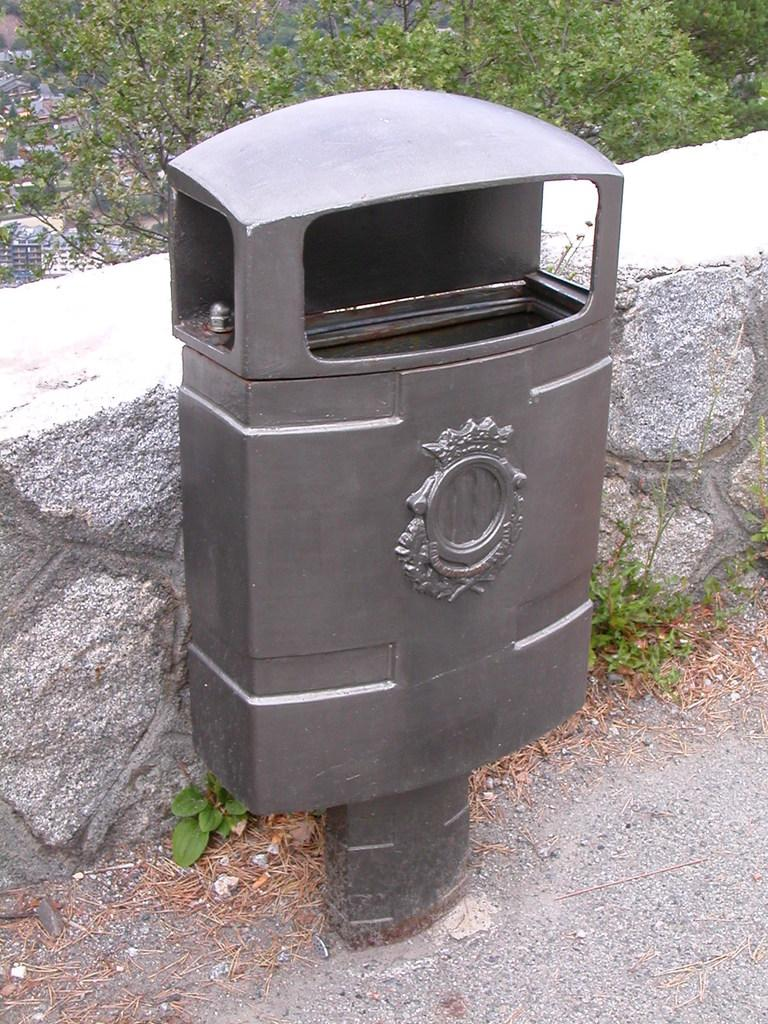What type of object is on the road in the image? There is a metal object on the road. What can be seen in the background of the image? There is a wall in the image. What is located behind the metal object on the road? There are trees behind the metal object. What type of salt can be seen on the kite in the image? There is no salt or kite present in the image. What invention is being used by the trees in the image? There is no invention associated with the trees in the image. 